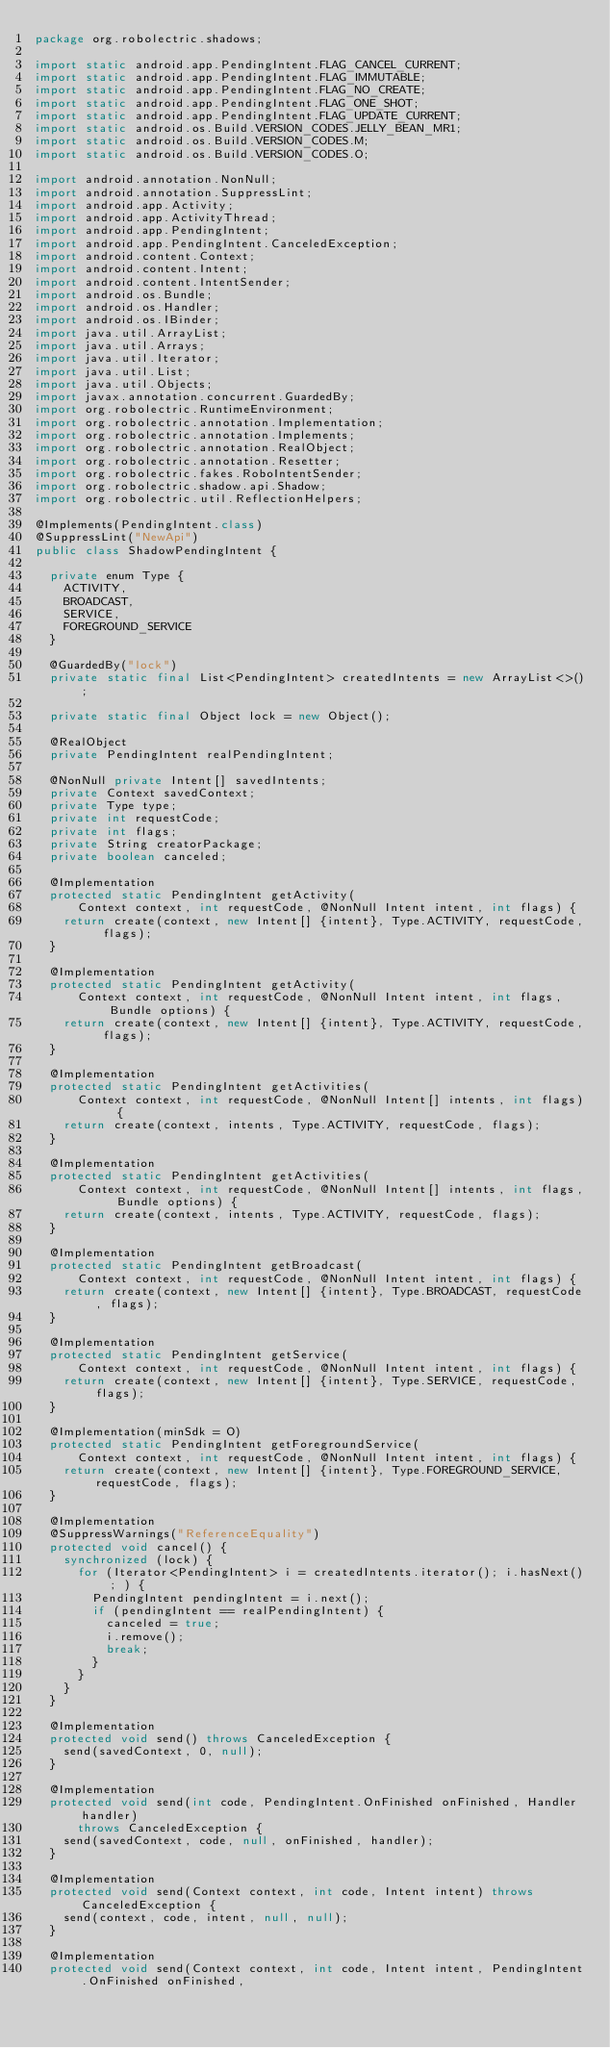<code> <loc_0><loc_0><loc_500><loc_500><_Java_>package org.robolectric.shadows;

import static android.app.PendingIntent.FLAG_CANCEL_CURRENT;
import static android.app.PendingIntent.FLAG_IMMUTABLE;
import static android.app.PendingIntent.FLAG_NO_CREATE;
import static android.app.PendingIntent.FLAG_ONE_SHOT;
import static android.app.PendingIntent.FLAG_UPDATE_CURRENT;
import static android.os.Build.VERSION_CODES.JELLY_BEAN_MR1;
import static android.os.Build.VERSION_CODES.M;
import static android.os.Build.VERSION_CODES.O;

import android.annotation.NonNull;
import android.annotation.SuppressLint;
import android.app.Activity;
import android.app.ActivityThread;
import android.app.PendingIntent;
import android.app.PendingIntent.CanceledException;
import android.content.Context;
import android.content.Intent;
import android.content.IntentSender;
import android.os.Bundle;
import android.os.Handler;
import android.os.IBinder;
import java.util.ArrayList;
import java.util.Arrays;
import java.util.Iterator;
import java.util.List;
import java.util.Objects;
import javax.annotation.concurrent.GuardedBy;
import org.robolectric.RuntimeEnvironment;
import org.robolectric.annotation.Implementation;
import org.robolectric.annotation.Implements;
import org.robolectric.annotation.RealObject;
import org.robolectric.annotation.Resetter;
import org.robolectric.fakes.RoboIntentSender;
import org.robolectric.shadow.api.Shadow;
import org.robolectric.util.ReflectionHelpers;

@Implements(PendingIntent.class)
@SuppressLint("NewApi")
public class ShadowPendingIntent {

  private enum Type {
    ACTIVITY,
    BROADCAST,
    SERVICE,
    FOREGROUND_SERVICE
  }

  @GuardedBy("lock")
  private static final List<PendingIntent> createdIntents = new ArrayList<>();

  private static final Object lock = new Object();

  @RealObject
  private PendingIntent realPendingIntent;

  @NonNull private Intent[] savedIntents;
  private Context savedContext;
  private Type type;
  private int requestCode;
  private int flags;
  private String creatorPackage;
  private boolean canceled;

  @Implementation
  protected static PendingIntent getActivity(
      Context context, int requestCode, @NonNull Intent intent, int flags) {
    return create(context, new Intent[] {intent}, Type.ACTIVITY, requestCode, flags);
  }

  @Implementation
  protected static PendingIntent getActivity(
      Context context, int requestCode, @NonNull Intent intent, int flags, Bundle options) {
    return create(context, new Intent[] {intent}, Type.ACTIVITY, requestCode, flags);
  }

  @Implementation
  protected static PendingIntent getActivities(
      Context context, int requestCode, @NonNull Intent[] intents, int flags) {
    return create(context, intents, Type.ACTIVITY, requestCode, flags);
  }

  @Implementation
  protected static PendingIntent getActivities(
      Context context, int requestCode, @NonNull Intent[] intents, int flags, Bundle options) {
    return create(context, intents, Type.ACTIVITY, requestCode, flags);
  }

  @Implementation
  protected static PendingIntent getBroadcast(
      Context context, int requestCode, @NonNull Intent intent, int flags) {
    return create(context, new Intent[] {intent}, Type.BROADCAST, requestCode, flags);
  }

  @Implementation
  protected static PendingIntent getService(
      Context context, int requestCode, @NonNull Intent intent, int flags) {
    return create(context, new Intent[] {intent}, Type.SERVICE, requestCode, flags);
  }

  @Implementation(minSdk = O)
  protected static PendingIntent getForegroundService(
      Context context, int requestCode, @NonNull Intent intent, int flags) {
    return create(context, new Intent[] {intent}, Type.FOREGROUND_SERVICE, requestCode, flags);
  }

  @Implementation
  @SuppressWarnings("ReferenceEquality")
  protected void cancel() {
    synchronized (lock) {
      for (Iterator<PendingIntent> i = createdIntents.iterator(); i.hasNext(); ) {
        PendingIntent pendingIntent = i.next();
        if (pendingIntent == realPendingIntent) {
          canceled = true;
          i.remove();
          break;
        }
      }
    }
  }

  @Implementation
  protected void send() throws CanceledException {
    send(savedContext, 0, null);
  }

  @Implementation
  protected void send(int code, PendingIntent.OnFinished onFinished, Handler handler)
      throws CanceledException {
    send(savedContext, code, null, onFinished, handler);
  }

  @Implementation
  protected void send(Context context, int code, Intent intent) throws CanceledException {
    send(context, code, intent, null, null);
  }

  @Implementation
  protected void send(Context context, int code, Intent intent, PendingIntent.OnFinished onFinished,</code> 